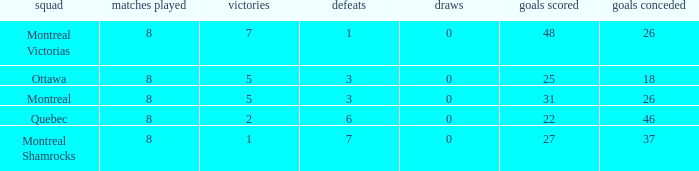For teams with 7 wins, what is the number of goals against? 26.0. 